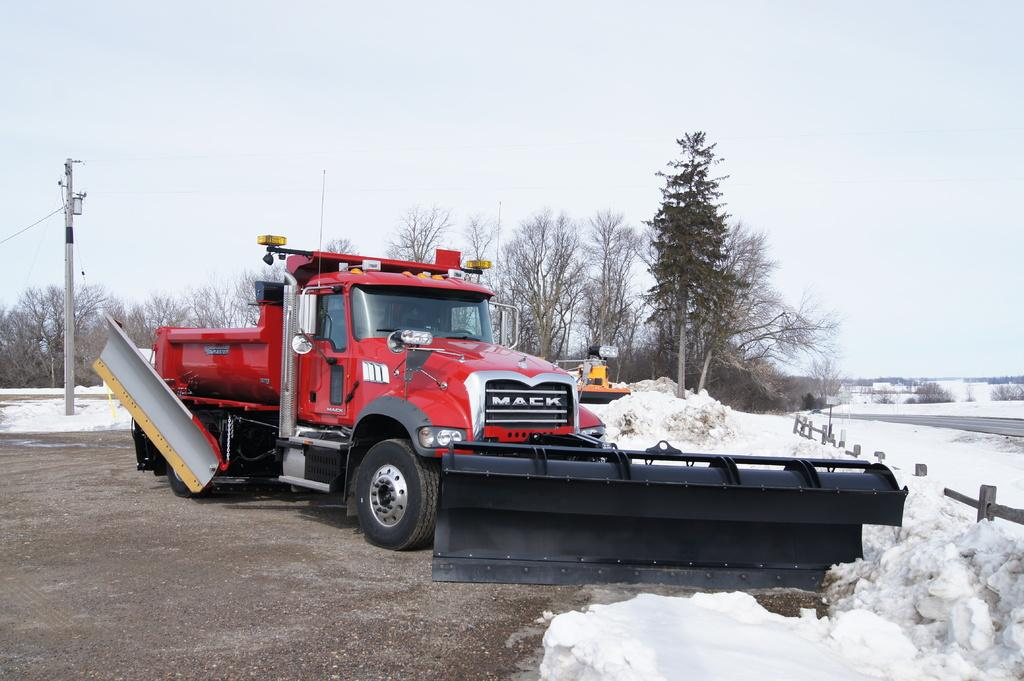What is the main subject of the image? There is a vehicle in the image. What is the weather condition in the image? There is snow in the image. What can be seen near the vehicle? There is a fence in the image. What is visible in the background of the image? There are trees, a pole, and the sky visible in the background of the image. How does the rake compare to the vehicle in the image? There is no rake present in the image, so it cannot be compared to the vehicle. 